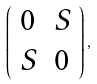<formula> <loc_0><loc_0><loc_500><loc_500>\left ( \begin{array} { c c } 0 & S \\ S & 0 \end{array} \right ) ,</formula> 